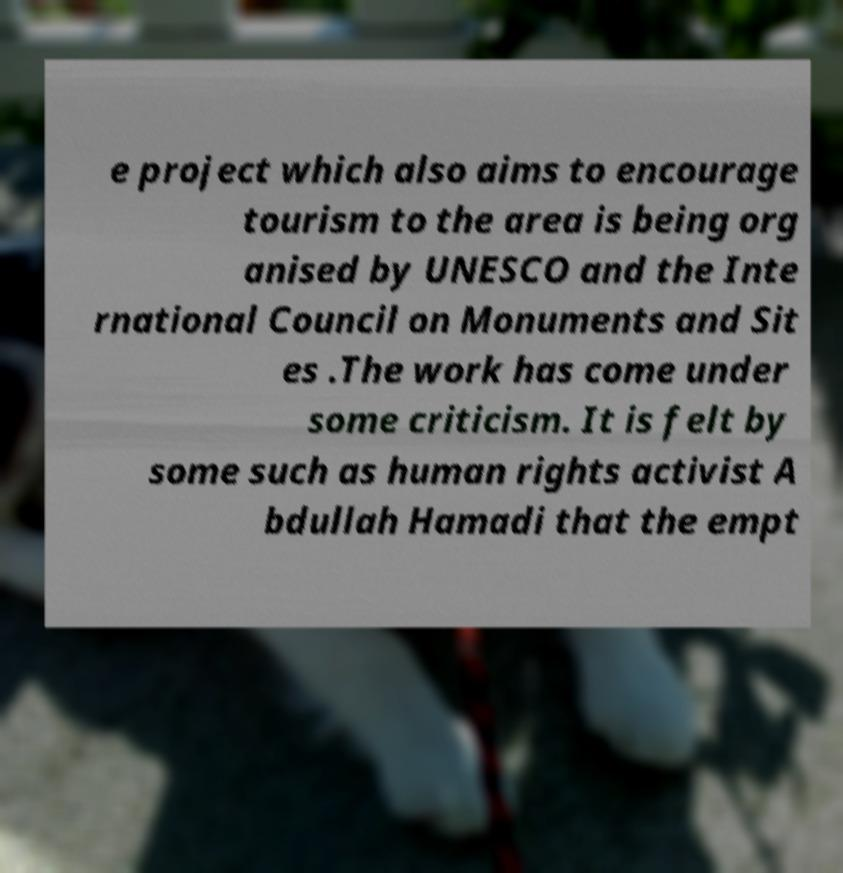Can you accurately transcribe the text from the provided image for me? e project which also aims to encourage tourism to the area is being org anised by UNESCO and the Inte rnational Council on Monuments and Sit es .The work has come under some criticism. It is felt by some such as human rights activist A bdullah Hamadi that the empt 